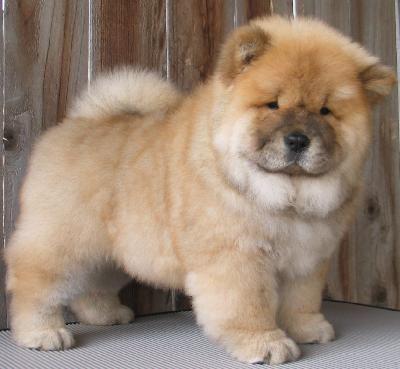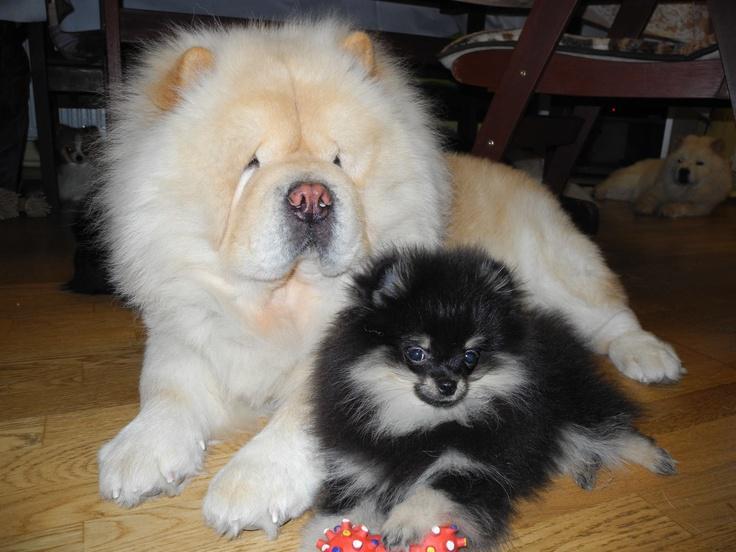The first image is the image on the left, the second image is the image on the right. Assess this claim about the two images: "One of the dogs is standing and looking toward the camera.". Correct or not? Answer yes or no. Yes. The first image is the image on the left, the second image is the image on the right. Given the left and right images, does the statement "A total of three dogs are shown in the foreground of the combined images." hold true? Answer yes or no. Yes. 